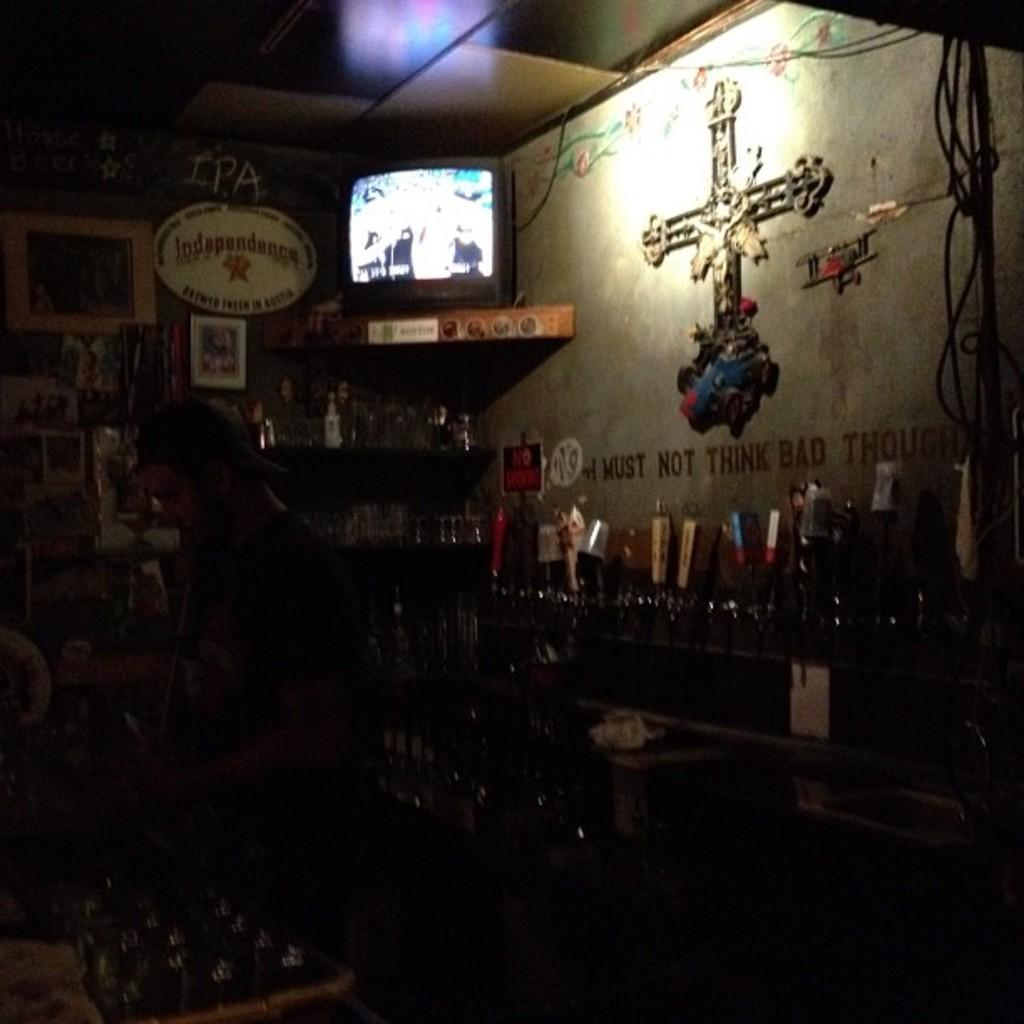What is the overall lighting condition in the image? The image has a dark view. What electronic device is present in the image? There is a monitor in the image. Where is the monitor located? The monitor is on a table. How is the table positioned in the image? The table is attached to the wall. What type of coast can be seen in the image? There is no coast visible in the image; it features a monitor on a table. Is there a partner working with the person in the image? There is no indication of a partner or another person in the image. 